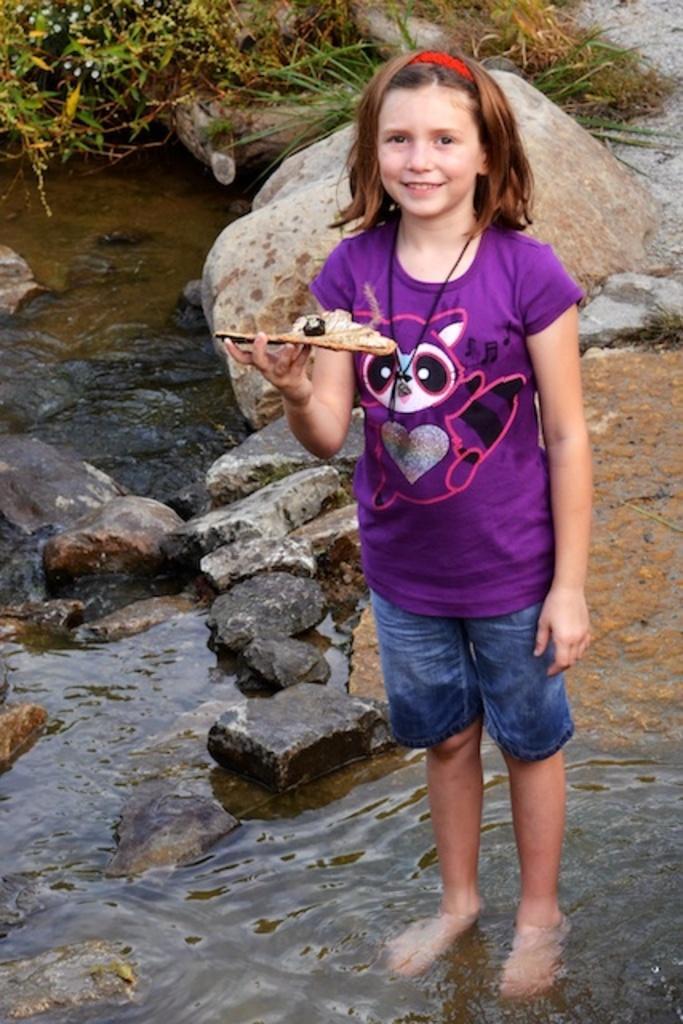In one or two sentences, can you explain what this image depicts? In this image we can see a girl wearing a red band and holding an object, standing in the water. And left side we can see water and stony surface. And right side we can see stones and greenery and sand. 